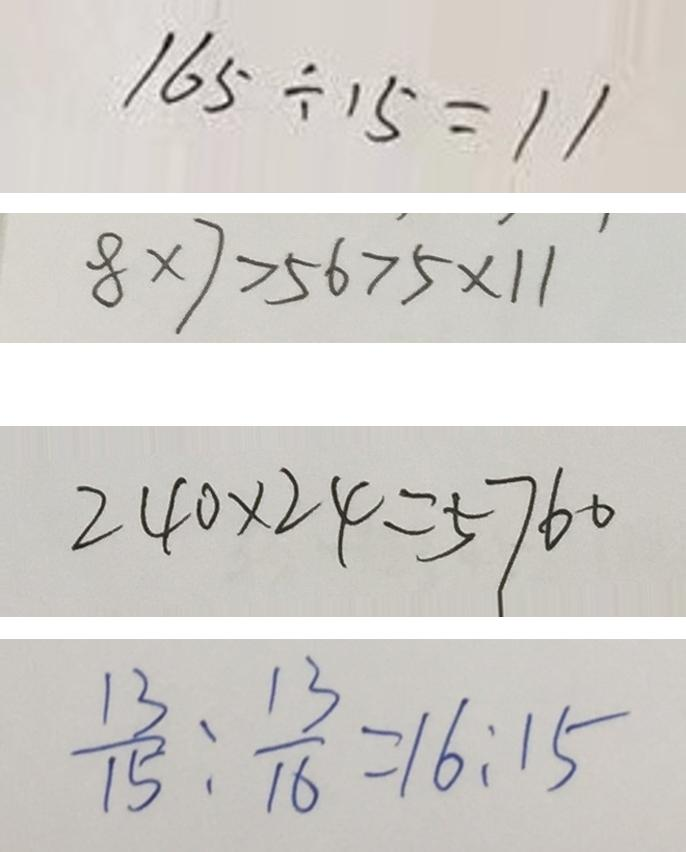<formula> <loc_0><loc_0><loc_500><loc_500>1 6 5 \div 1 5 = 1 1 
 8 \times 7 > 5 6 > 5 \times 1 1 
 2 4 0 \times 2 4 = 5 7 6 0 
 \frac { 1 3 } { 1 5 } : \frac { 1 3 } { 1 6 } = 1 6 : 1 5</formula> 